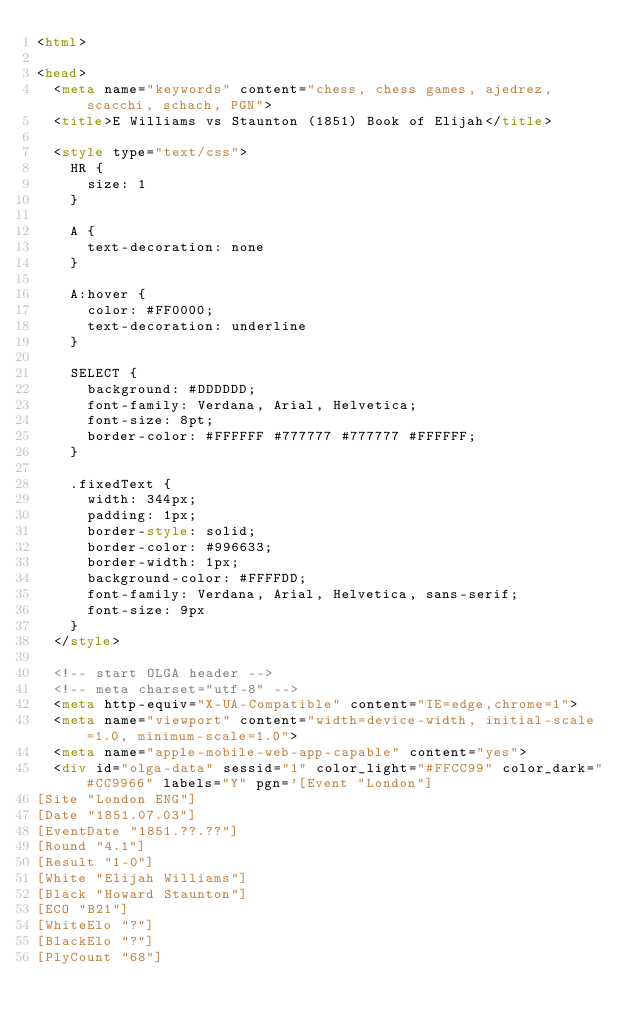Convert code to text. <code><loc_0><loc_0><loc_500><loc_500><_HTML_><html>

<head>
  <meta name="keywords" content="chess, chess games, ajedrez, scacchi, schach, PGN">
  <title>E Williams vs Staunton (1851) Book of Elijah</title>

  <style type="text/css">
    HR {
      size: 1
    }

    A {
      text-decoration: none
    }

    A:hover {
      color: #FF0000;
      text-decoration: underline
    }

    SELECT {
      background: #DDDDDD;
      font-family: Verdana, Arial, Helvetica;
      font-size: 8pt;
      border-color: #FFFFFF #777777 #777777 #FFFFFF;
    }

    .fixedText {
      width: 344px;
      padding: 1px;
      border-style: solid;
      border-color: #996633;
      border-width: 1px;
      background-color: #FFFFDD;
      font-family: Verdana, Arial, Helvetica, sans-serif;
      font-size: 9px
    }
  </style>

  <!-- start OLGA header -->
  <!-- meta charset="utf-8" -->
  <meta http-equiv="X-UA-Compatible" content="IE=edge,chrome=1">
  <meta name="viewport" content="width=device-width, initial-scale=1.0, minimum-scale=1.0">
  <meta name="apple-mobile-web-app-capable" content="yes">
  <div id="olga-data" sessid="1" color_light="#FFCC99" color_dark="#CC9966" labels="Y" pgn='[Event "London"]
[Site "London ENG"]
[Date "1851.07.03"]
[EventDate "1851.??.??"]
[Round "4.1"]
[Result "1-0"]
[White "Elijah Williams"]
[Black "Howard Staunton"]
[ECO "B21"]
[WhiteElo "?"]
[BlackElo "?"]
[PlyCount "68"]
</code> 